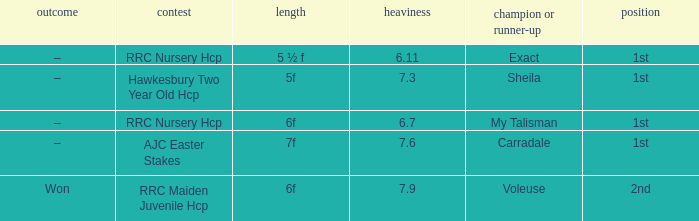What was the name of the winner or 2nd when the result was –, and weight was 6.7? My Talisman. 